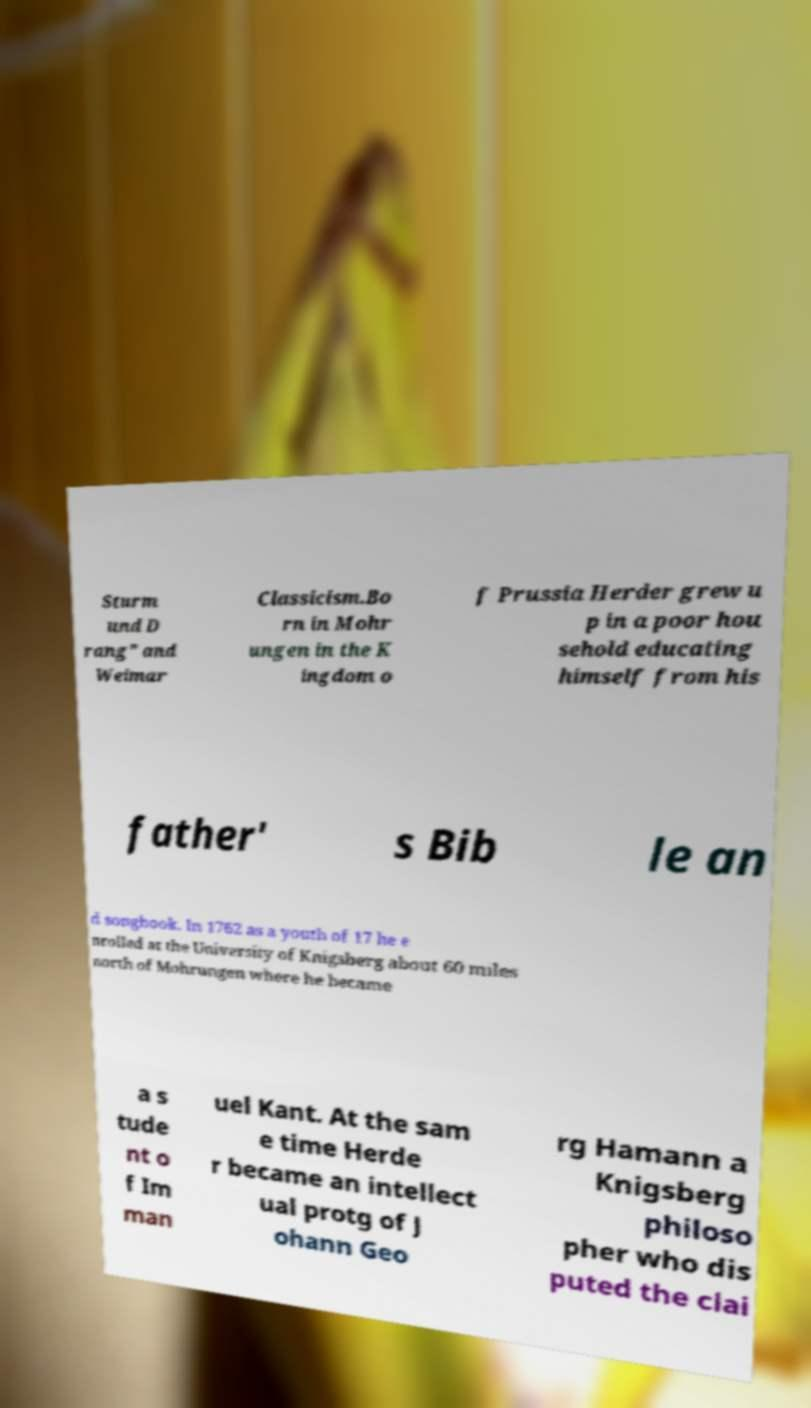Could you extract and type out the text from this image? Sturm und D rang" and Weimar Classicism.Bo rn in Mohr ungen in the K ingdom o f Prussia Herder grew u p in a poor hou sehold educating himself from his father' s Bib le an d songbook. In 1762 as a youth of 17 he e nrolled at the University of Knigsberg about 60 miles north of Mohrungen where he became a s tude nt o f Im man uel Kant. At the sam e time Herde r became an intellect ual protg of J ohann Geo rg Hamann a Knigsberg philoso pher who dis puted the clai 